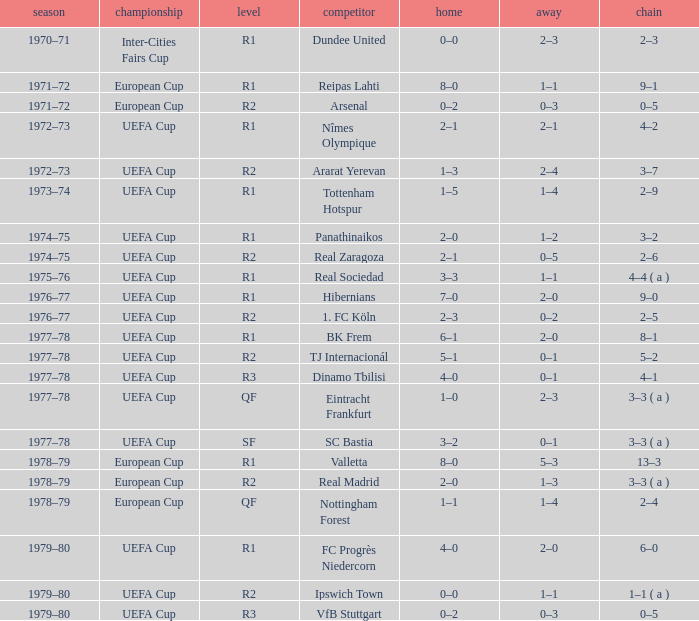Which Series has a Home of 2–0, and an Opponent of panathinaikos? 3–2. Help me parse the entirety of this table. {'header': ['season', 'championship', 'level', 'competitor', 'home', 'away', 'chain'], 'rows': [['1970–71', 'Inter-Cities Fairs Cup', 'R1', 'Dundee United', '0–0', '2–3', '2–3'], ['1971–72', 'European Cup', 'R1', 'Reipas Lahti', '8–0', '1–1', '9–1'], ['1971–72', 'European Cup', 'R2', 'Arsenal', '0–2', '0–3', '0–5'], ['1972–73', 'UEFA Cup', 'R1', 'Nîmes Olympique', '2–1', '2–1', '4–2'], ['1972–73', 'UEFA Cup', 'R2', 'Ararat Yerevan', '1–3', '2–4', '3–7'], ['1973–74', 'UEFA Cup', 'R1', 'Tottenham Hotspur', '1–5', '1–4', '2–9'], ['1974–75', 'UEFA Cup', 'R1', 'Panathinaikos', '2–0', '1–2', '3–2'], ['1974–75', 'UEFA Cup', 'R2', 'Real Zaragoza', '2–1', '0–5', '2–6'], ['1975–76', 'UEFA Cup', 'R1', 'Real Sociedad', '3–3', '1–1', '4–4 ( a )'], ['1976–77', 'UEFA Cup', 'R1', 'Hibernians', '7–0', '2–0', '9–0'], ['1976–77', 'UEFA Cup', 'R2', '1. FC Köln', '2–3', '0–2', '2–5'], ['1977–78', 'UEFA Cup', 'R1', 'BK Frem', '6–1', '2–0', '8–1'], ['1977–78', 'UEFA Cup', 'R2', 'TJ Internacionál', '5–1', '0–1', '5–2'], ['1977–78', 'UEFA Cup', 'R3', 'Dinamo Tbilisi', '4–0', '0–1', '4–1'], ['1977–78', 'UEFA Cup', 'QF', 'Eintracht Frankfurt', '1–0', '2–3', '3–3 ( a )'], ['1977–78', 'UEFA Cup', 'SF', 'SC Bastia', '3–2', '0–1', '3–3 ( a )'], ['1978–79', 'European Cup', 'R1', 'Valletta', '8–0', '5–3', '13–3'], ['1978–79', 'European Cup', 'R2', 'Real Madrid', '2–0', '1–3', '3–3 ( a )'], ['1978–79', 'European Cup', 'QF', 'Nottingham Forest', '1–1', '1–4', '2–4'], ['1979–80', 'UEFA Cup', 'R1', 'FC Progrès Niedercorn', '4–0', '2–0', '6–0'], ['1979–80', 'UEFA Cup', 'R2', 'Ipswich Town', '0–0', '1–1', '1–1 ( a )'], ['1979–80', 'UEFA Cup', 'R3', 'VfB Stuttgart', '0–2', '0–3', '0–5']]} 